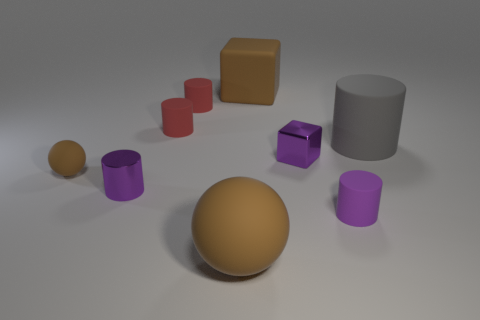There is another object that is the same shape as the tiny brown object; what material is it?
Your answer should be compact. Rubber. Is there any other thing that is the same color as the large cube?
Keep it short and to the point. Yes. What is the color of the small rubber thing that is in front of the small brown object that is on the left side of the brown cube?
Your answer should be compact. Purple. Are there fewer brown rubber cubes that are on the right side of the shiny cube than small purple metal cubes to the left of the large ball?
Offer a very short reply. No. There is a large cube that is the same color as the tiny ball; what material is it?
Ensure brevity in your answer.  Rubber. What number of objects are matte things that are in front of the tiny purple matte cylinder or small purple matte things?
Keep it short and to the point. 2. Do the purple cylinder that is behind the purple rubber cylinder and the big gray matte object have the same size?
Offer a terse response. No. Is the number of cubes in front of the metallic block less than the number of red cylinders?
Provide a succinct answer. Yes. What material is the brown object that is the same size as the purple metallic block?
Your response must be concise. Rubber. What number of tiny things are purple objects or matte blocks?
Keep it short and to the point. 3. 